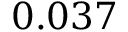<formula> <loc_0><loc_0><loc_500><loc_500>0 . 0 3 7</formula> 